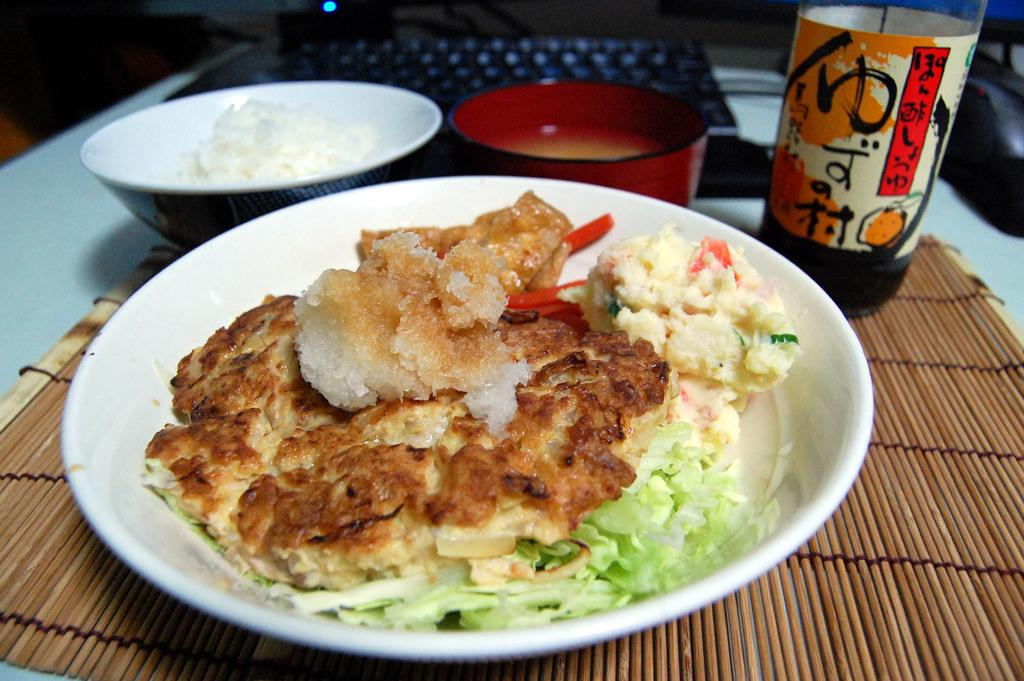What is the main piece of furniture in the image? There is a table in the image. What items are placed on the table? There are bowls, a laptop, a bottle, a dining mat, and food placed on the table. What type of electronic device is on the table? There is a laptop on the table. What might be used to protect the table from spills or heat? The dining mat on the table might be used to protect the table from spills or heat. Can you see any roots growing from the table in the image? There are no roots visible in the image; it features a table with various items placed on it. Is there a volcano erupting in the background of the image? There is no volcano present in the image; it features a table with various items placed on it. 